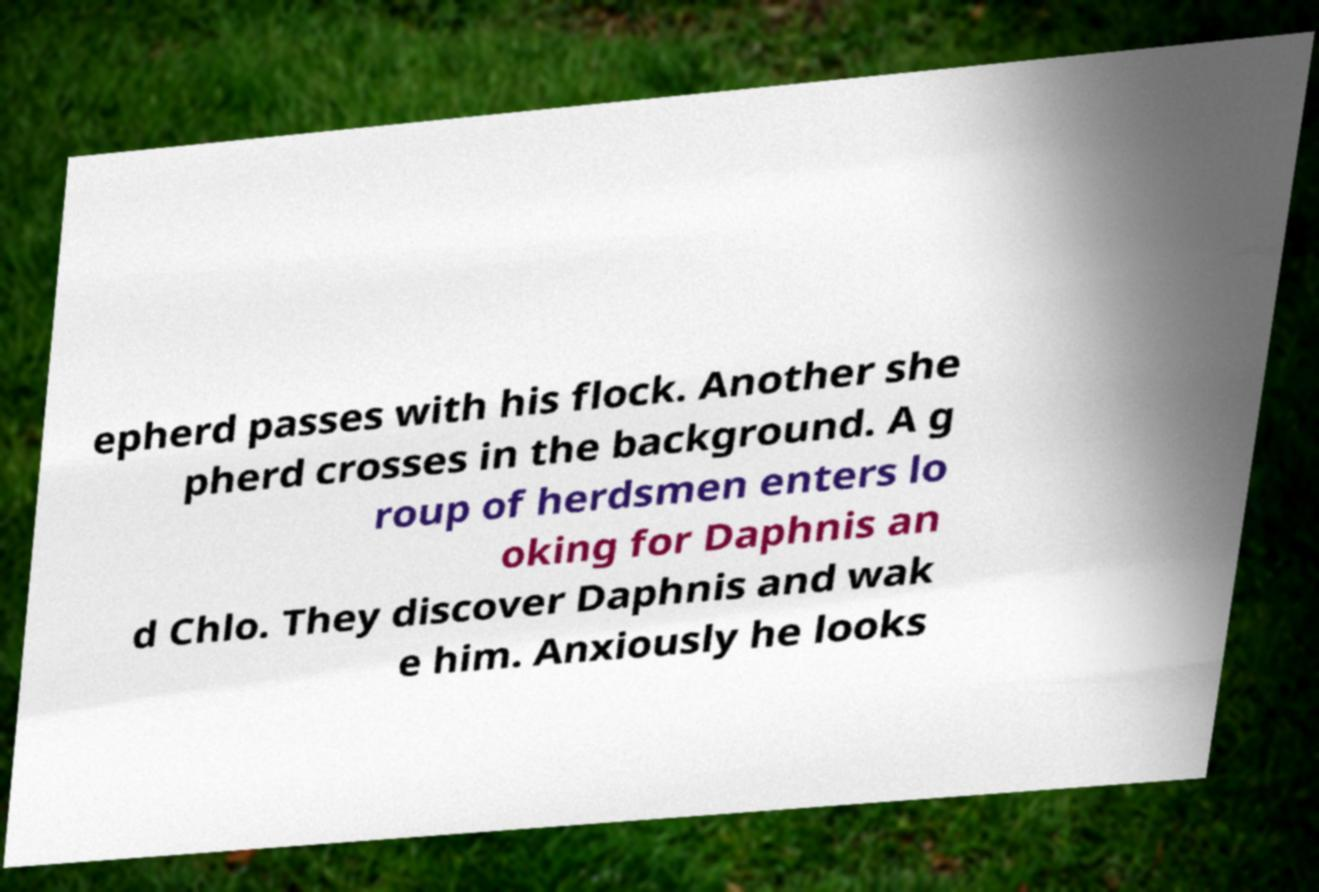What messages or text are displayed in this image? I need them in a readable, typed format. epherd passes with his flock. Another she pherd crosses in the background. A g roup of herdsmen enters lo oking for Daphnis an d Chlo. They discover Daphnis and wak e him. Anxiously he looks 